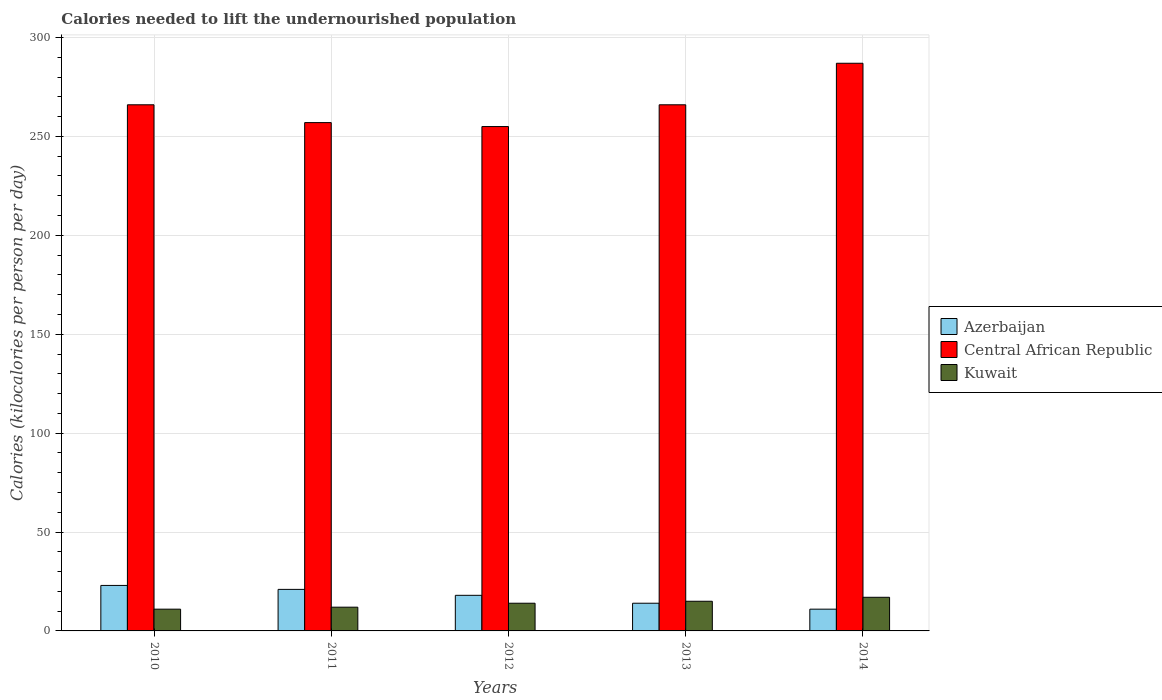How many different coloured bars are there?
Offer a very short reply. 3. How many bars are there on the 3rd tick from the left?
Offer a very short reply. 3. What is the total calories needed to lift the undernourished population in Central African Republic in 2010?
Make the answer very short. 266. Across all years, what is the maximum total calories needed to lift the undernourished population in Kuwait?
Make the answer very short. 17. Across all years, what is the minimum total calories needed to lift the undernourished population in Azerbaijan?
Your answer should be very brief. 11. What is the total total calories needed to lift the undernourished population in Kuwait in the graph?
Your answer should be compact. 69. What is the difference between the total calories needed to lift the undernourished population in Azerbaijan in 2010 and that in 2012?
Make the answer very short. 5. What is the difference between the total calories needed to lift the undernourished population in Central African Republic in 2014 and the total calories needed to lift the undernourished population in Kuwait in 2013?
Provide a short and direct response. 272. What is the average total calories needed to lift the undernourished population in Kuwait per year?
Ensure brevity in your answer.  13.8. In the year 2013, what is the difference between the total calories needed to lift the undernourished population in Kuwait and total calories needed to lift the undernourished population in Azerbaijan?
Offer a very short reply. 1. In how many years, is the total calories needed to lift the undernourished population in Kuwait greater than 110 kilocalories?
Your answer should be compact. 0. What is the ratio of the total calories needed to lift the undernourished population in Kuwait in 2012 to that in 2013?
Keep it short and to the point. 0.93. Is the total calories needed to lift the undernourished population in Kuwait in 2010 less than that in 2012?
Ensure brevity in your answer.  Yes. What is the difference between the highest and the second highest total calories needed to lift the undernourished population in Kuwait?
Give a very brief answer. 2. What is the difference between the highest and the lowest total calories needed to lift the undernourished population in Azerbaijan?
Make the answer very short. 12. In how many years, is the total calories needed to lift the undernourished population in Kuwait greater than the average total calories needed to lift the undernourished population in Kuwait taken over all years?
Provide a succinct answer. 3. Is the sum of the total calories needed to lift the undernourished population in Central African Republic in 2011 and 2012 greater than the maximum total calories needed to lift the undernourished population in Azerbaijan across all years?
Provide a succinct answer. Yes. What does the 1st bar from the left in 2010 represents?
Ensure brevity in your answer.  Azerbaijan. What does the 1st bar from the right in 2010 represents?
Offer a very short reply. Kuwait. How many years are there in the graph?
Your answer should be very brief. 5. What is the difference between two consecutive major ticks on the Y-axis?
Provide a short and direct response. 50. Are the values on the major ticks of Y-axis written in scientific E-notation?
Give a very brief answer. No. Does the graph contain grids?
Your answer should be very brief. Yes. Where does the legend appear in the graph?
Offer a very short reply. Center right. How many legend labels are there?
Your answer should be compact. 3. How are the legend labels stacked?
Your answer should be compact. Vertical. What is the title of the graph?
Make the answer very short. Calories needed to lift the undernourished population. What is the label or title of the Y-axis?
Give a very brief answer. Calories (kilocalories per person per day). What is the Calories (kilocalories per person per day) in Central African Republic in 2010?
Your answer should be very brief. 266. What is the Calories (kilocalories per person per day) of Kuwait in 2010?
Keep it short and to the point. 11. What is the Calories (kilocalories per person per day) in Central African Republic in 2011?
Offer a terse response. 257. What is the Calories (kilocalories per person per day) of Central African Republic in 2012?
Provide a short and direct response. 255. What is the Calories (kilocalories per person per day) in Kuwait in 2012?
Keep it short and to the point. 14. What is the Calories (kilocalories per person per day) in Central African Republic in 2013?
Make the answer very short. 266. What is the Calories (kilocalories per person per day) of Kuwait in 2013?
Offer a terse response. 15. What is the Calories (kilocalories per person per day) in Azerbaijan in 2014?
Give a very brief answer. 11. What is the Calories (kilocalories per person per day) of Central African Republic in 2014?
Offer a very short reply. 287. What is the Calories (kilocalories per person per day) in Kuwait in 2014?
Give a very brief answer. 17. Across all years, what is the maximum Calories (kilocalories per person per day) in Azerbaijan?
Keep it short and to the point. 23. Across all years, what is the maximum Calories (kilocalories per person per day) in Central African Republic?
Your response must be concise. 287. Across all years, what is the maximum Calories (kilocalories per person per day) in Kuwait?
Your answer should be compact. 17. Across all years, what is the minimum Calories (kilocalories per person per day) of Azerbaijan?
Offer a very short reply. 11. Across all years, what is the minimum Calories (kilocalories per person per day) in Central African Republic?
Your answer should be compact. 255. What is the total Calories (kilocalories per person per day) in Central African Republic in the graph?
Give a very brief answer. 1331. What is the total Calories (kilocalories per person per day) of Kuwait in the graph?
Make the answer very short. 69. What is the difference between the Calories (kilocalories per person per day) of Azerbaijan in 2010 and that in 2011?
Ensure brevity in your answer.  2. What is the difference between the Calories (kilocalories per person per day) of Kuwait in 2010 and that in 2011?
Offer a terse response. -1. What is the difference between the Calories (kilocalories per person per day) in Azerbaijan in 2010 and that in 2012?
Your answer should be very brief. 5. What is the difference between the Calories (kilocalories per person per day) in Central African Republic in 2010 and that in 2012?
Offer a terse response. 11. What is the difference between the Calories (kilocalories per person per day) of Kuwait in 2010 and that in 2012?
Offer a very short reply. -3. What is the difference between the Calories (kilocalories per person per day) in Central African Republic in 2010 and that in 2013?
Your answer should be very brief. 0. What is the difference between the Calories (kilocalories per person per day) of Kuwait in 2010 and that in 2014?
Your answer should be very brief. -6. What is the difference between the Calories (kilocalories per person per day) of Central African Republic in 2011 and that in 2012?
Ensure brevity in your answer.  2. What is the difference between the Calories (kilocalories per person per day) in Azerbaijan in 2011 and that in 2013?
Keep it short and to the point. 7. What is the difference between the Calories (kilocalories per person per day) of Central African Republic in 2011 and that in 2013?
Provide a short and direct response. -9. What is the difference between the Calories (kilocalories per person per day) of Azerbaijan in 2011 and that in 2014?
Provide a succinct answer. 10. What is the difference between the Calories (kilocalories per person per day) of Central African Republic in 2011 and that in 2014?
Provide a succinct answer. -30. What is the difference between the Calories (kilocalories per person per day) of Kuwait in 2011 and that in 2014?
Provide a succinct answer. -5. What is the difference between the Calories (kilocalories per person per day) in Azerbaijan in 2012 and that in 2013?
Your response must be concise. 4. What is the difference between the Calories (kilocalories per person per day) in Central African Republic in 2012 and that in 2014?
Ensure brevity in your answer.  -32. What is the difference between the Calories (kilocalories per person per day) in Kuwait in 2012 and that in 2014?
Make the answer very short. -3. What is the difference between the Calories (kilocalories per person per day) of Kuwait in 2013 and that in 2014?
Give a very brief answer. -2. What is the difference between the Calories (kilocalories per person per day) in Azerbaijan in 2010 and the Calories (kilocalories per person per day) in Central African Republic in 2011?
Ensure brevity in your answer.  -234. What is the difference between the Calories (kilocalories per person per day) of Azerbaijan in 2010 and the Calories (kilocalories per person per day) of Kuwait in 2011?
Ensure brevity in your answer.  11. What is the difference between the Calories (kilocalories per person per day) of Central African Republic in 2010 and the Calories (kilocalories per person per day) of Kuwait in 2011?
Your response must be concise. 254. What is the difference between the Calories (kilocalories per person per day) in Azerbaijan in 2010 and the Calories (kilocalories per person per day) in Central African Republic in 2012?
Your response must be concise. -232. What is the difference between the Calories (kilocalories per person per day) of Azerbaijan in 2010 and the Calories (kilocalories per person per day) of Kuwait in 2012?
Your answer should be compact. 9. What is the difference between the Calories (kilocalories per person per day) in Central African Republic in 2010 and the Calories (kilocalories per person per day) in Kuwait in 2012?
Provide a succinct answer. 252. What is the difference between the Calories (kilocalories per person per day) of Azerbaijan in 2010 and the Calories (kilocalories per person per day) of Central African Republic in 2013?
Your answer should be very brief. -243. What is the difference between the Calories (kilocalories per person per day) of Azerbaijan in 2010 and the Calories (kilocalories per person per day) of Kuwait in 2013?
Offer a very short reply. 8. What is the difference between the Calories (kilocalories per person per day) in Central African Republic in 2010 and the Calories (kilocalories per person per day) in Kuwait in 2013?
Keep it short and to the point. 251. What is the difference between the Calories (kilocalories per person per day) of Azerbaijan in 2010 and the Calories (kilocalories per person per day) of Central African Republic in 2014?
Offer a terse response. -264. What is the difference between the Calories (kilocalories per person per day) in Azerbaijan in 2010 and the Calories (kilocalories per person per day) in Kuwait in 2014?
Give a very brief answer. 6. What is the difference between the Calories (kilocalories per person per day) of Central African Republic in 2010 and the Calories (kilocalories per person per day) of Kuwait in 2014?
Keep it short and to the point. 249. What is the difference between the Calories (kilocalories per person per day) in Azerbaijan in 2011 and the Calories (kilocalories per person per day) in Central African Republic in 2012?
Keep it short and to the point. -234. What is the difference between the Calories (kilocalories per person per day) in Central African Republic in 2011 and the Calories (kilocalories per person per day) in Kuwait in 2012?
Offer a terse response. 243. What is the difference between the Calories (kilocalories per person per day) in Azerbaijan in 2011 and the Calories (kilocalories per person per day) in Central African Republic in 2013?
Keep it short and to the point. -245. What is the difference between the Calories (kilocalories per person per day) in Azerbaijan in 2011 and the Calories (kilocalories per person per day) in Kuwait in 2013?
Your answer should be very brief. 6. What is the difference between the Calories (kilocalories per person per day) of Central African Republic in 2011 and the Calories (kilocalories per person per day) of Kuwait in 2013?
Your response must be concise. 242. What is the difference between the Calories (kilocalories per person per day) in Azerbaijan in 2011 and the Calories (kilocalories per person per day) in Central African Republic in 2014?
Your answer should be compact. -266. What is the difference between the Calories (kilocalories per person per day) of Central African Republic in 2011 and the Calories (kilocalories per person per day) of Kuwait in 2014?
Your answer should be compact. 240. What is the difference between the Calories (kilocalories per person per day) in Azerbaijan in 2012 and the Calories (kilocalories per person per day) in Central African Republic in 2013?
Give a very brief answer. -248. What is the difference between the Calories (kilocalories per person per day) of Central African Republic in 2012 and the Calories (kilocalories per person per day) of Kuwait in 2013?
Your answer should be very brief. 240. What is the difference between the Calories (kilocalories per person per day) of Azerbaijan in 2012 and the Calories (kilocalories per person per day) of Central African Republic in 2014?
Keep it short and to the point. -269. What is the difference between the Calories (kilocalories per person per day) of Azerbaijan in 2012 and the Calories (kilocalories per person per day) of Kuwait in 2014?
Ensure brevity in your answer.  1. What is the difference between the Calories (kilocalories per person per day) of Central African Republic in 2012 and the Calories (kilocalories per person per day) of Kuwait in 2014?
Your answer should be very brief. 238. What is the difference between the Calories (kilocalories per person per day) of Azerbaijan in 2013 and the Calories (kilocalories per person per day) of Central African Republic in 2014?
Offer a terse response. -273. What is the difference between the Calories (kilocalories per person per day) in Central African Republic in 2013 and the Calories (kilocalories per person per day) in Kuwait in 2014?
Make the answer very short. 249. What is the average Calories (kilocalories per person per day) in Azerbaijan per year?
Provide a short and direct response. 17.4. What is the average Calories (kilocalories per person per day) of Central African Republic per year?
Keep it short and to the point. 266.2. What is the average Calories (kilocalories per person per day) of Kuwait per year?
Make the answer very short. 13.8. In the year 2010, what is the difference between the Calories (kilocalories per person per day) in Azerbaijan and Calories (kilocalories per person per day) in Central African Republic?
Your answer should be very brief. -243. In the year 2010, what is the difference between the Calories (kilocalories per person per day) of Azerbaijan and Calories (kilocalories per person per day) of Kuwait?
Provide a succinct answer. 12. In the year 2010, what is the difference between the Calories (kilocalories per person per day) in Central African Republic and Calories (kilocalories per person per day) in Kuwait?
Ensure brevity in your answer.  255. In the year 2011, what is the difference between the Calories (kilocalories per person per day) of Azerbaijan and Calories (kilocalories per person per day) of Central African Republic?
Provide a succinct answer. -236. In the year 2011, what is the difference between the Calories (kilocalories per person per day) in Azerbaijan and Calories (kilocalories per person per day) in Kuwait?
Your response must be concise. 9. In the year 2011, what is the difference between the Calories (kilocalories per person per day) of Central African Republic and Calories (kilocalories per person per day) of Kuwait?
Make the answer very short. 245. In the year 2012, what is the difference between the Calories (kilocalories per person per day) in Azerbaijan and Calories (kilocalories per person per day) in Central African Republic?
Your answer should be compact. -237. In the year 2012, what is the difference between the Calories (kilocalories per person per day) of Azerbaijan and Calories (kilocalories per person per day) of Kuwait?
Your answer should be compact. 4. In the year 2012, what is the difference between the Calories (kilocalories per person per day) in Central African Republic and Calories (kilocalories per person per day) in Kuwait?
Make the answer very short. 241. In the year 2013, what is the difference between the Calories (kilocalories per person per day) in Azerbaijan and Calories (kilocalories per person per day) in Central African Republic?
Your response must be concise. -252. In the year 2013, what is the difference between the Calories (kilocalories per person per day) in Azerbaijan and Calories (kilocalories per person per day) in Kuwait?
Give a very brief answer. -1. In the year 2013, what is the difference between the Calories (kilocalories per person per day) of Central African Republic and Calories (kilocalories per person per day) of Kuwait?
Provide a short and direct response. 251. In the year 2014, what is the difference between the Calories (kilocalories per person per day) of Azerbaijan and Calories (kilocalories per person per day) of Central African Republic?
Provide a short and direct response. -276. In the year 2014, what is the difference between the Calories (kilocalories per person per day) of Azerbaijan and Calories (kilocalories per person per day) of Kuwait?
Make the answer very short. -6. In the year 2014, what is the difference between the Calories (kilocalories per person per day) in Central African Republic and Calories (kilocalories per person per day) in Kuwait?
Your answer should be very brief. 270. What is the ratio of the Calories (kilocalories per person per day) in Azerbaijan in 2010 to that in 2011?
Offer a terse response. 1.1. What is the ratio of the Calories (kilocalories per person per day) of Central African Republic in 2010 to that in 2011?
Make the answer very short. 1.03. What is the ratio of the Calories (kilocalories per person per day) of Azerbaijan in 2010 to that in 2012?
Provide a succinct answer. 1.28. What is the ratio of the Calories (kilocalories per person per day) in Central African Republic in 2010 to that in 2012?
Your answer should be compact. 1.04. What is the ratio of the Calories (kilocalories per person per day) of Kuwait in 2010 to that in 2012?
Provide a short and direct response. 0.79. What is the ratio of the Calories (kilocalories per person per day) of Azerbaijan in 2010 to that in 2013?
Offer a terse response. 1.64. What is the ratio of the Calories (kilocalories per person per day) of Kuwait in 2010 to that in 2013?
Offer a very short reply. 0.73. What is the ratio of the Calories (kilocalories per person per day) in Azerbaijan in 2010 to that in 2014?
Offer a terse response. 2.09. What is the ratio of the Calories (kilocalories per person per day) of Central African Republic in 2010 to that in 2014?
Your answer should be compact. 0.93. What is the ratio of the Calories (kilocalories per person per day) in Kuwait in 2010 to that in 2014?
Ensure brevity in your answer.  0.65. What is the ratio of the Calories (kilocalories per person per day) of Azerbaijan in 2011 to that in 2012?
Your response must be concise. 1.17. What is the ratio of the Calories (kilocalories per person per day) in Central African Republic in 2011 to that in 2012?
Keep it short and to the point. 1.01. What is the ratio of the Calories (kilocalories per person per day) of Central African Republic in 2011 to that in 2013?
Make the answer very short. 0.97. What is the ratio of the Calories (kilocalories per person per day) of Azerbaijan in 2011 to that in 2014?
Keep it short and to the point. 1.91. What is the ratio of the Calories (kilocalories per person per day) of Central African Republic in 2011 to that in 2014?
Give a very brief answer. 0.9. What is the ratio of the Calories (kilocalories per person per day) of Kuwait in 2011 to that in 2014?
Keep it short and to the point. 0.71. What is the ratio of the Calories (kilocalories per person per day) in Azerbaijan in 2012 to that in 2013?
Your response must be concise. 1.29. What is the ratio of the Calories (kilocalories per person per day) of Central African Republic in 2012 to that in 2013?
Offer a terse response. 0.96. What is the ratio of the Calories (kilocalories per person per day) in Kuwait in 2012 to that in 2013?
Offer a terse response. 0.93. What is the ratio of the Calories (kilocalories per person per day) of Azerbaijan in 2012 to that in 2014?
Offer a terse response. 1.64. What is the ratio of the Calories (kilocalories per person per day) in Central African Republic in 2012 to that in 2014?
Ensure brevity in your answer.  0.89. What is the ratio of the Calories (kilocalories per person per day) in Kuwait in 2012 to that in 2014?
Give a very brief answer. 0.82. What is the ratio of the Calories (kilocalories per person per day) in Azerbaijan in 2013 to that in 2014?
Keep it short and to the point. 1.27. What is the ratio of the Calories (kilocalories per person per day) in Central African Republic in 2013 to that in 2014?
Offer a very short reply. 0.93. What is the ratio of the Calories (kilocalories per person per day) of Kuwait in 2013 to that in 2014?
Offer a terse response. 0.88. What is the difference between the highest and the second highest Calories (kilocalories per person per day) of Kuwait?
Your answer should be compact. 2. What is the difference between the highest and the lowest Calories (kilocalories per person per day) in Central African Republic?
Ensure brevity in your answer.  32. 